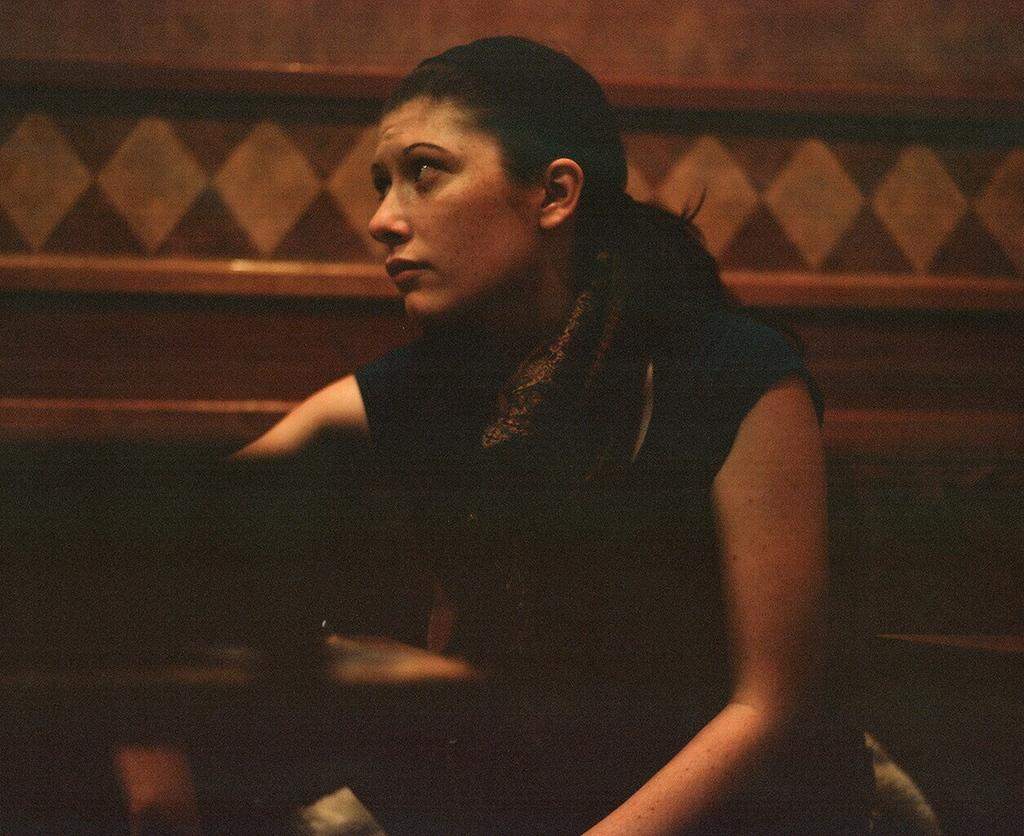Who is present in the image? There is a woman in the image. What is the woman doing in the image? The woman is sitting on a chair. What other furniture is visible in the image? There is a table in the image. What can be seen in the background of the image? There is a wall visible in the background of the image. What type of cart is being used for the woman's development in the image? There is no cart or development mentioned or depicted in the image; it only features a woman sitting on a chair with a table and a wall in the background. 